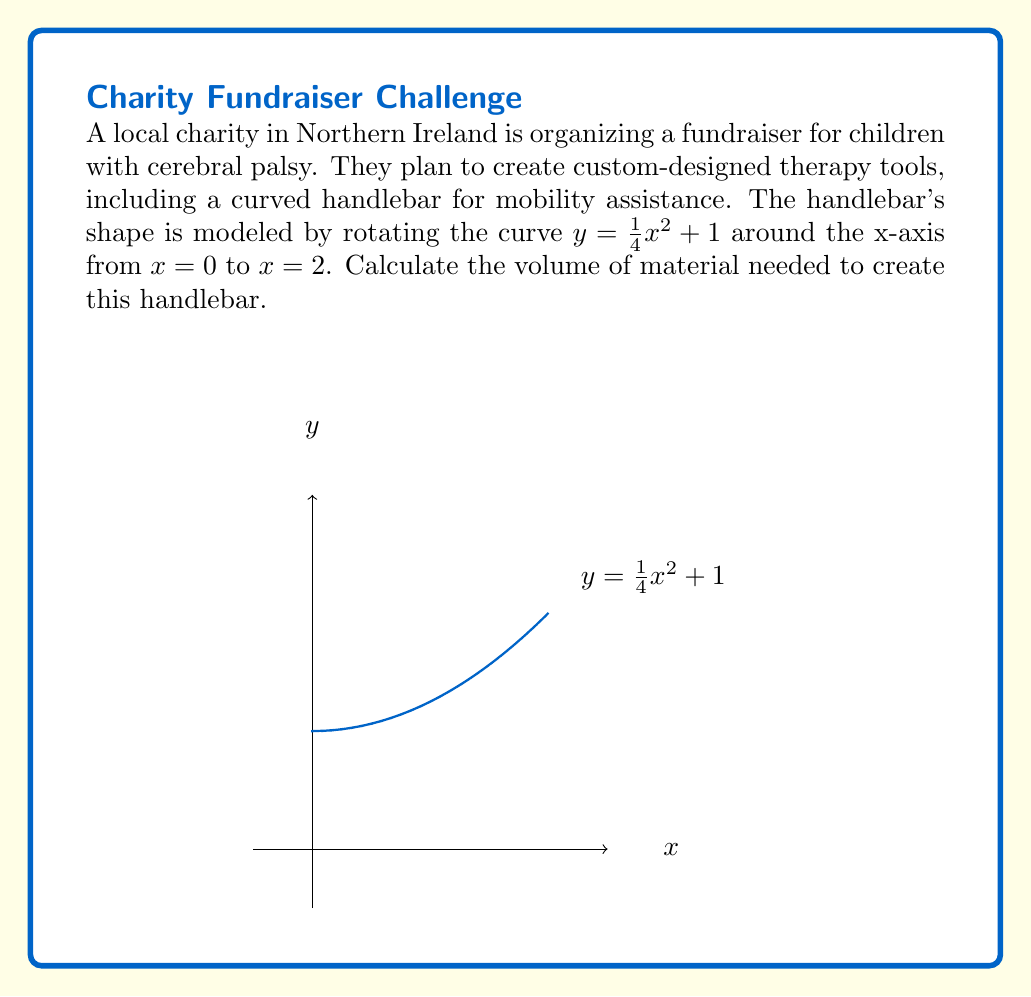Show me your answer to this math problem. To find the volume of the solid of revolution, we'll use the disk method:

1) The volume is given by the integral:
   $$V = \pi \int_a^b [f(x)]^2 dx$$
   where $f(x) = \frac{1}{4}x^2 + 1$, $a = 0$, and $b = 2$.

2) Substituting these into the formula:
   $$V = \pi \int_0^2 [\frac{1}{4}x^2 + 1]^2 dx$$

3) Expand the squared term:
   $$V = \pi \int_0^2 [\frac{1}{16}x^4 + \frac{1}{2}x^2 + 1] dx$$

4) Integrate term by term:
   $$V = \pi [\frac{1}{80}x^5 + \frac{1}{6}x^3 + x]_0^2$$

5) Evaluate the integral:
   $$V = \pi [(\frac{1}{80}(32) + \frac{1}{6}(8) + 2) - (0 + 0 + 0)]$$
   $$V = \pi [\frac{2}{5} + \frac{4}{3} + 2]$$
   $$V = \pi [\frac{12}{15} + \frac{20}{15} + \frac{30}{15}]$$
   $$V = \pi [\frac{62}{15}]$$

6) Simplify:
   $$V = \frac{62\pi}{15} \approx 13.0107$$

Therefore, the volume of material needed is approximately 13.0107 cubic units.
Answer: $\frac{62\pi}{15}$ cubic units 